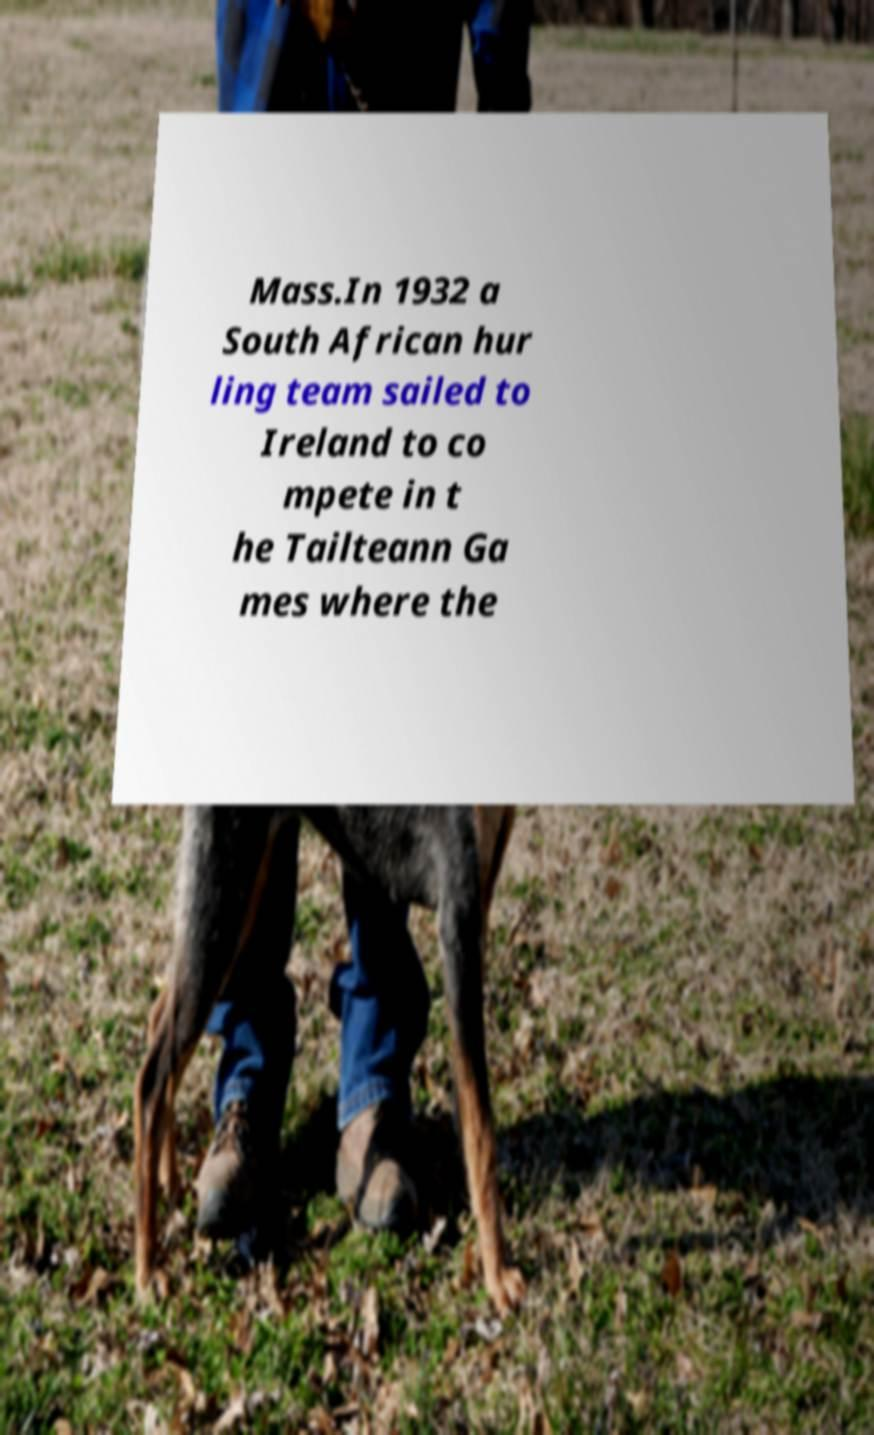What messages or text are displayed in this image? I need them in a readable, typed format. Mass.In 1932 a South African hur ling team sailed to Ireland to co mpete in t he Tailteann Ga mes where the 